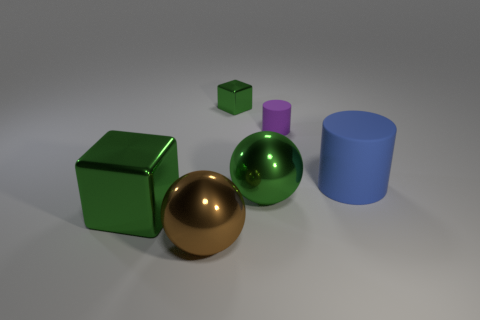What materials do the objects in the image appear to be made of? The objects in the image seem to be rendered with different textures suggesting various materials. The brown and green spheres, as well as the pink and blue cylinders, have a glossy finish, indicating they could be made of a polished metal or plastic. The green cube has a matte finish, perhaps resembling painted wood or a non-reflective plastic. 